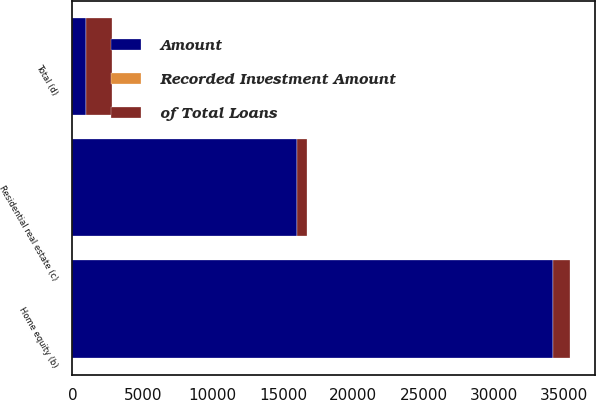Convert chart. <chart><loc_0><loc_0><loc_500><loc_500><stacked_bar_chart><ecel><fcel>Home equity (b)<fcel>Residential real estate (c)<fcel>Total (d)<nl><fcel>of Total Loans<fcel>1203<fcel>671<fcel>1874<nl><fcel>Recorded Investment Amount<fcel>4<fcel>4<fcel>4<nl><fcel>Amount<fcel>34226<fcel>15999<fcel>937<nl></chart> 